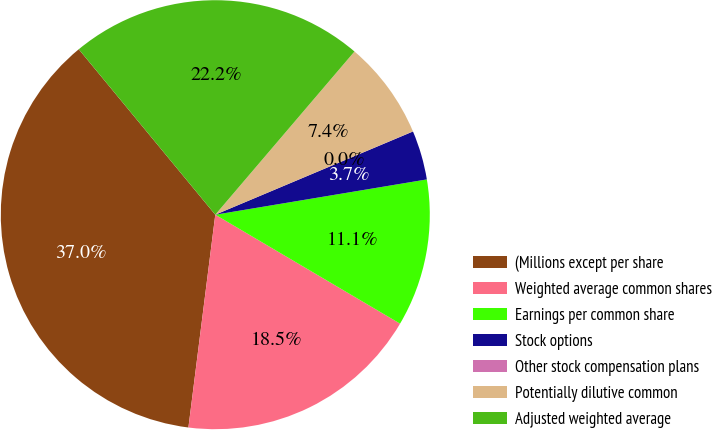<chart> <loc_0><loc_0><loc_500><loc_500><pie_chart><fcel>(Millions except per share<fcel>Weighted average common shares<fcel>Earnings per common share<fcel>Stock options<fcel>Other stock compensation plans<fcel>Potentially dilutive common<fcel>Adjusted weighted average<nl><fcel>37.02%<fcel>18.52%<fcel>11.11%<fcel>3.71%<fcel>0.01%<fcel>7.41%<fcel>22.22%<nl></chart> 